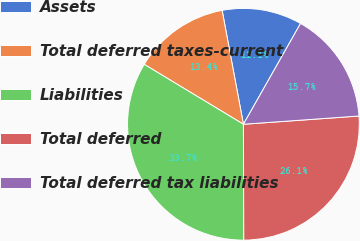Convert chart to OTSL. <chart><loc_0><loc_0><loc_500><loc_500><pie_chart><fcel>Assets<fcel>Total deferred taxes-current<fcel>Liabilities<fcel>Total deferred<fcel>Total deferred tax liabilities<nl><fcel>11.15%<fcel>13.41%<fcel>33.7%<fcel>26.08%<fcel>15.66%<nl></chart> 